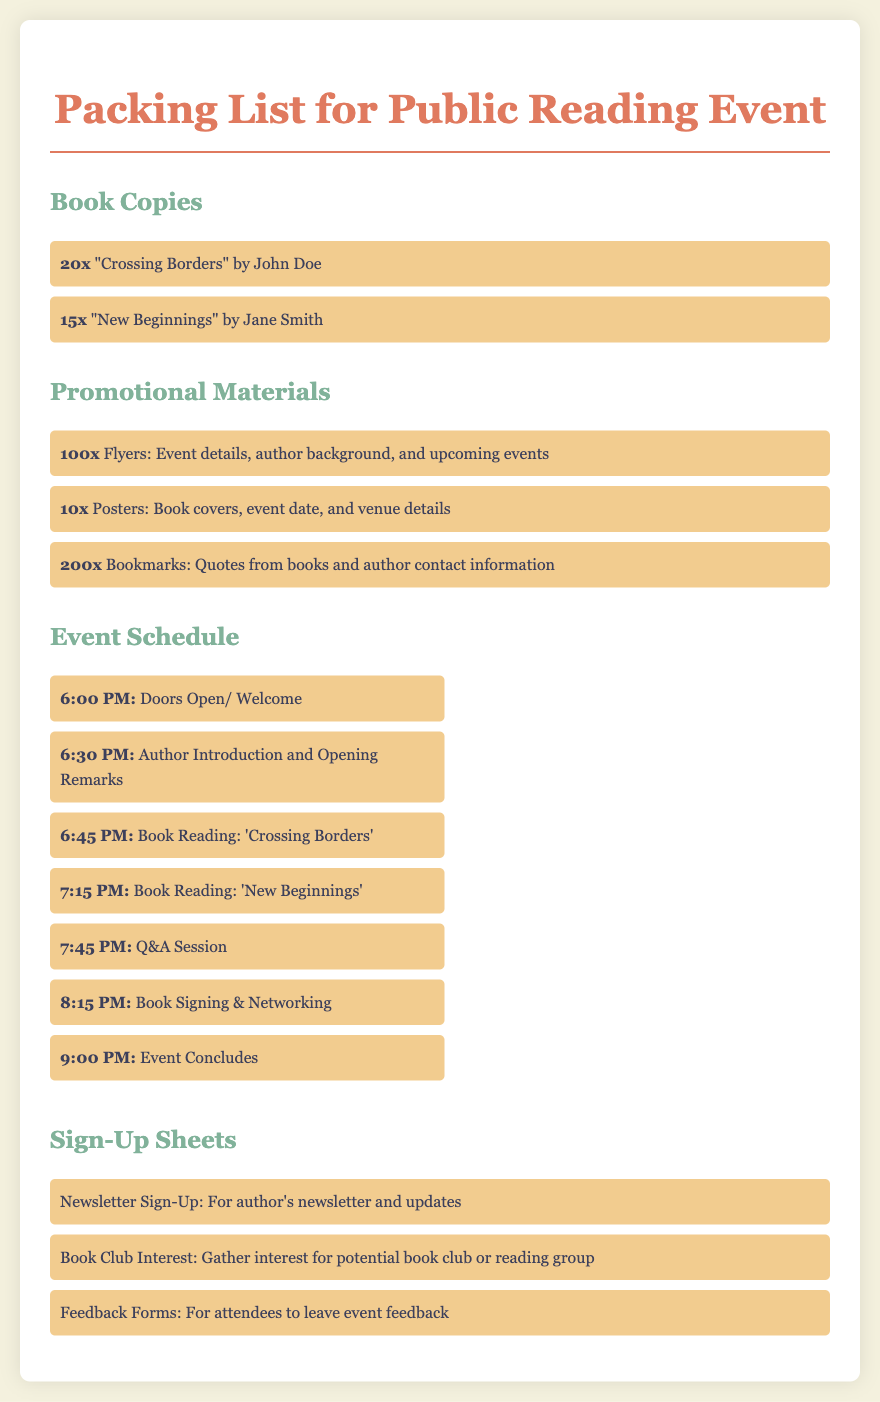What is the title of the first book listed? The title of the first book listed under "Book Copies" is "Crossing Borders".
Answer: "Crossing Borders" How many copies of "New Beginnings" are being brought? The document states that there are 15 copies of "New Beginnings".
Answer: 15x What type of promotional material is there 100 copies of? The document lists 100 flyers containing event details, author background, and upcoming events.
Answer: Flyers What item is scheduled for 7:15 PM? The document indicates that 'New Beginnings' is scheduled for reading at 7:15 PM.
Answer: Book Reading: 'New Beginnings' How many bookmarks are included in the promotional materials? The list shows that there are 200 bookmarks with quotes from books and author contact information.
Answer: 200x What time does the event conclude? The document states that the event concludes at 9:00 PM.
Answer: 9:00 PM What kind of sign-up sheet is included for book clubs? The document mentions a "Book Club Interest" sign-up sheet to gather interest for potential book clubs.
Answer: Book Club Interest What is the purpose of the Feedback Forms? According to the document, Feedback Forms are for attendees to leave event feedback.
Answer: Event feedback How many promotional posters are being brought? The document states that there are 10 promotional posters.
Answer: 10x 